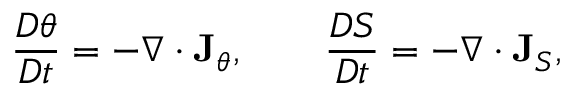Convert formula to latex. <formula><loc_0><loc_0><loc_500><loc_500>\frac { D \theta } { D t } = - \nabla \cdot { J } _ { \theta } , \quad \frac { D S } { D t } = - \nabla \cdot { J } _ { S } ,</formula> 